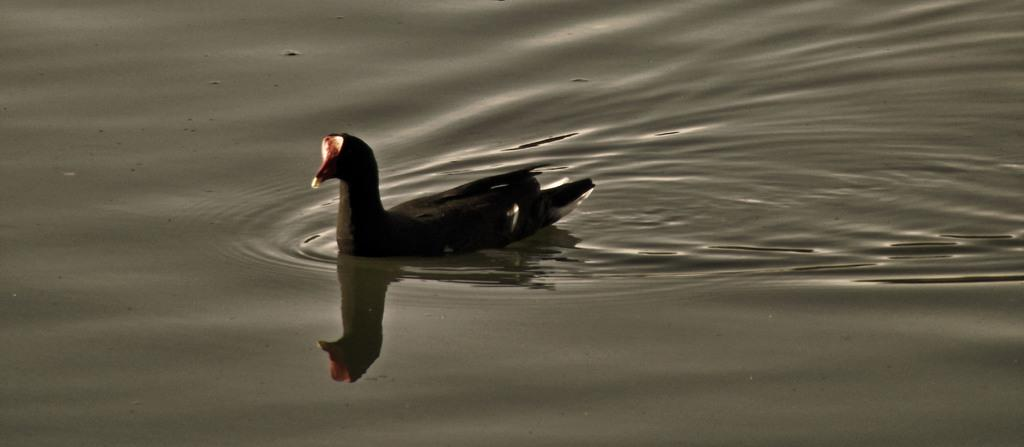What type of animal can be seen in the image? There is a bird in the image. Where is the bird located in the image? The bird is in the water. What type of ring is the bird wearing on its tongue in the image? There is no ring or any indication of a ring on the bird's tongue in the image. 